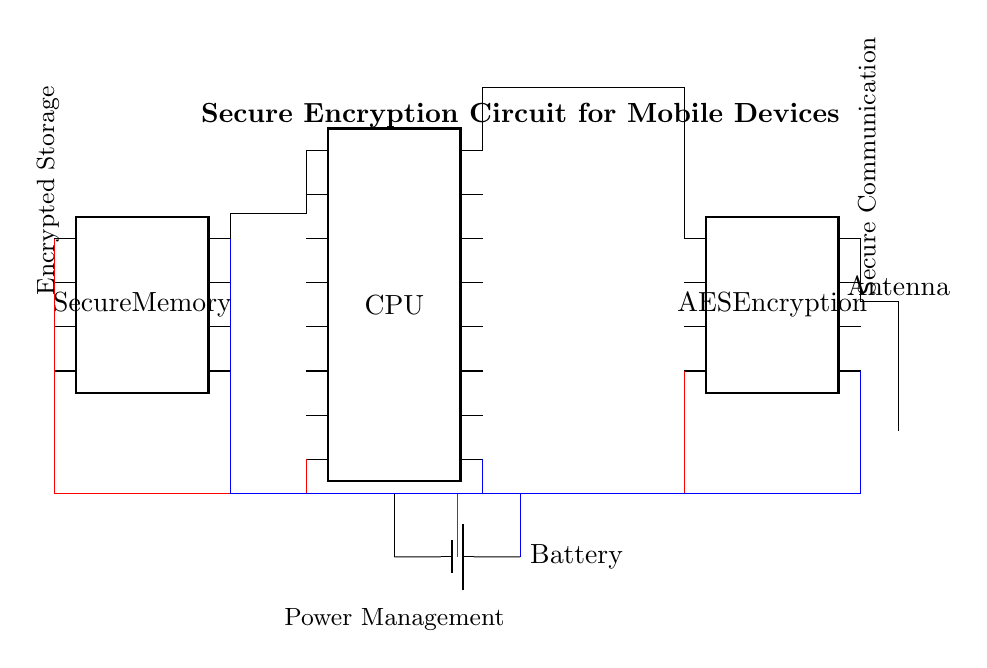What are the main components of this circuit? The main components visible in the circuit diagram include the CPU, AES Encryption module, Secure Memory, Battery, and Antenna. Each is represented as a unique icon in the diagram.
Answer: CPU, AES Encryption, Secure Memory, Battery, Antenna How many pins does the CPU have? The CPU is depicted as a chip with 16 pins, which are indicated by the number of connection points around its outline.
Answer: 16 pins Which component is responsible for encrypted storage? The Secure Memory is labeled as the component responsible for encrypted storage, as indicated by a label beside it on the diagram.
Answer: Secure Memory What is the purpose of the AES Encryption module? The AES Encryption module is designed to encrypt data before it is stored or transmitted, functioning as a security feature in the circuit. A label accompanies it explaining its role.
Answer: Encrypt data How do the CPU and AES Encryption module connect? The CPU connects to the AES Encryption module via pin 16 at the top, while at the bottom, a connection leads to the encryption module’s pin 1. This shows a direct interaction necessary for data encryption.
Answer: Direct connection What kind of communication is facilitated by the Antenna? The Antenna is labeled as facilitating secure communication, which implies that it is used for transmitting and receiving encrypted data. The label along with the component's position illustrates its purpose.
Answer: Secure communication Where does power come from in this circuit? Power is supplied by the Battery, which connects to multiple components via red lines indicating the power lines. The connection to the CPU also shows that it is receiving power from this source.
Answer: Battery 